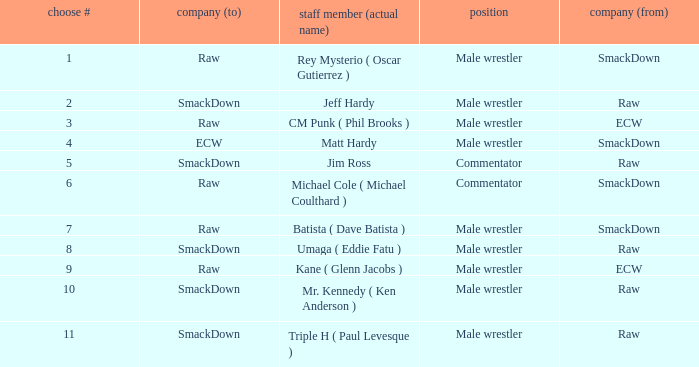What role did Pick # 10 have? Male wrestler. 